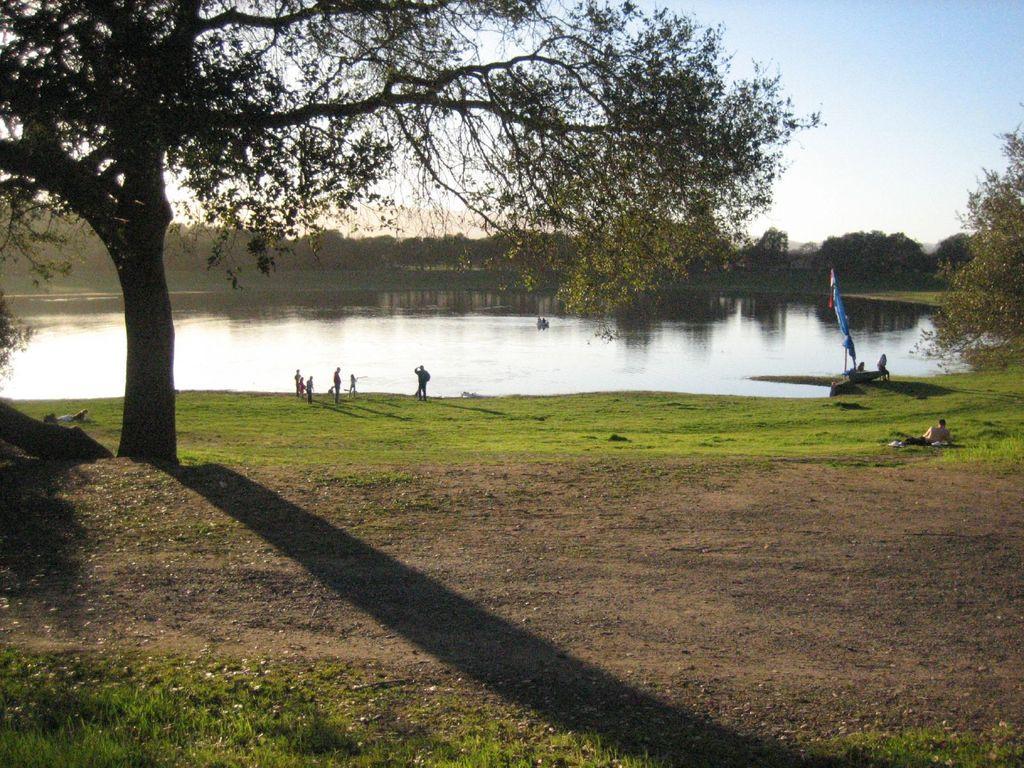Can you describe this image briefly? In the image there is a tree and around the tree there is a lot of grass and a person is lying on the grass,in front of that there is a pond and some people are standing in front of the pond,in the right side there is a flag. Behind the pond in the background there are plenty of trees. 